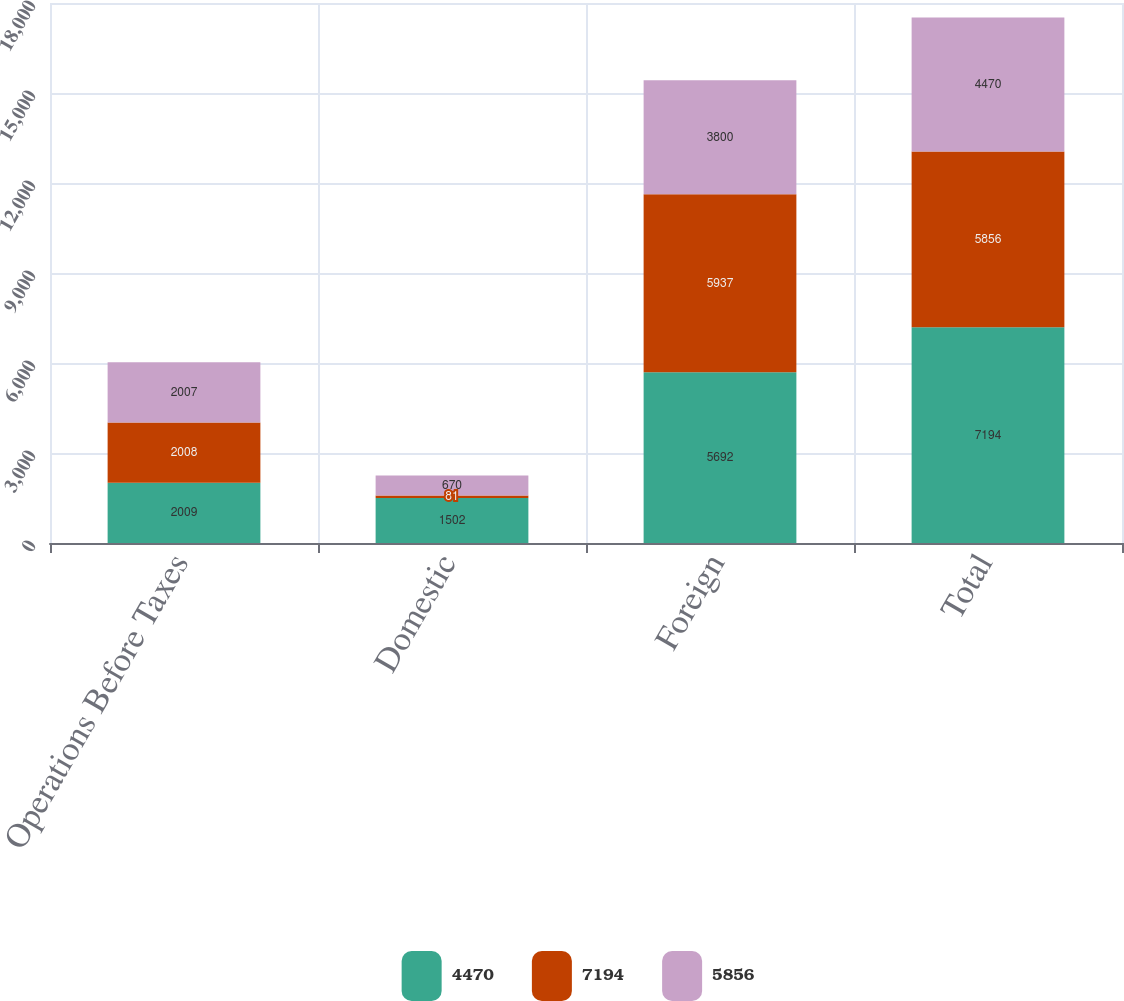<chart> <loc_0><loc_0><loc_500><loc_500><stacked_bar_chart><ecel><fcel>Operations Before Taxes<fcel>Domestic<fcel>Foreign<fcel>Total<nl><fcel>4470<fcel>2009<fcel>1502<fcel>5692<fcel>7194<nl><fcel>7194<fcel>2008<fcel>81<fcel>5937<fcel>5856<nl><fcel>5856<fcel>2007<fcel>670<fcel>3800<fcel>4470<nl></chart> 